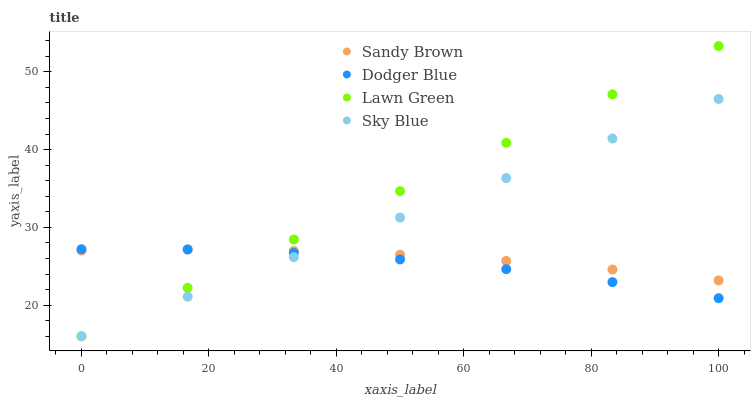Does Dodger Blue have the minimum area under the curve?
Answer yes or no. Yes. Does Lawn Green have the maximum area under the curve?
Answer yes or no. Yes. Does Sky Blue have the minimum area under the curve?
Answer yes or no. No. Does Sky Blue have the maximum area under the curve?
Answer yes or no. No. Is Sky Blue the smoothest?
Answer yes or no. Yes. Is Dodger Blue the roughest?
Answer yes or no. Yes. Is Sandy Brown the smoothest?
Answer yes or no. No. Is Sandy Brown the roughest?
Answer yes or no. No. Does Sky Blue have the lowest value?
Answer yes or no. Yes. Does Sandy Brown have the lowest value?
Answer yes or no. No. Does Lawn Green have the highest value?
Answer yes or no. Yes. Does Sky Blue have the highest value?
Answer yes or no. No. Does Sandy Brown intersect Sky Blue?
Answer yes or no. Yes. Is Sandy Brown less than Sky Blue?
Answer yes or no. No. Is Sandy Brown greater than Sky Blue?
Answer yes or no. No. 